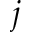Convert formula to latex. <formula><loc_0><loc_0><loc_500><loc_500>j</formula> 